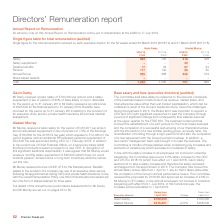According to Premier Foods Plc's financial document, What was the basic salary per annum of Mr Darby in 2017/18? According to the financial document, £700,000. The relevant text states: "Gavin Darby Mr Darby received a basic salary of £700,000 per annum and a salary supplement in lieu of pension of 20% of base salary on a pro rata basis for t..." Also, What was the basic salary of Mr Murray in 2018/19? According to the financial document, £416,201. The relevant text states: "r Murray received a basic salary for the period of £416,201 per annum and an annualised supplement in lieu of pension of 7.5% of the Earnings Cap (£160,800 for..." Also, What was the basic salary per annum of Mr Darby in 2018/19? According to the financial document, 583 (in thousands). The relevant text states: "2017/18 £’000 Salary 583 700 416 408 Salary supplement – – 40 – Taxable benefits 17 22 27 24 Pension 117 140 36 35 Annual Bo..." Also, can you calculate: What was the change in the salary of Gavin Darby from 2017/18 to 2018/19? Based on the calculation: 583 - 700, the result is -117 (in thousands). This is based on the information: "2017/18 £’000 Salary 583 700 416 408 Salary supplement – – 40 – Taxable benefits 17 22 27 24 Pension 117 140 36 35 Annual Bonus 2017/18 £’000 Salary 583 700 416 408 Salary supplement – – 40 – Taxable ..." The key data points involved are: 583, 700. Also, can you calculate: What is the average salary of Alastair Murray in 2017/18 and 2018/19? To answer this question, I need to perform calculations using the financial data. The calculation is: (416 + 408) / 2, which equals 412 (in thousands). This is based on the information: "2017/18 £’000 Salary 583 700 416 408 Salary supplement – – 40 – Taxable benefits 17 22 27 24 Pension 117 140 36 35 Annual Bonus 525 2017/18 £’000 Salary 583 700 416 408 Salary supplement – – 40 – Taxa..." The key data points involved are: 408, 416. Also, can you calculate: What was the average taxable benefits for Gavin Darby for 2017/18 and 2018/19? To answer this question, I need to perform calculations using the financial data. The calculation is: (17 + 22) / 2, which equals 19.5 (in thousands). This is based on the information: "08 Salary supplement – – 40 – Taxable benefits 17 22 27 24 Pension 117 140 36 35 Annual Bonus 525 368 232 153 Share based awards – – – – Total 1,242 1,2 6 408 Salary supplement – – 40 – Taxable benefi..." The key data points involved are: 17, 22. 